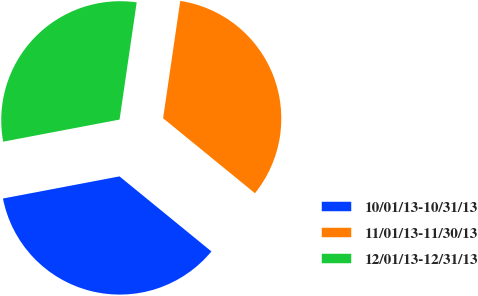Convert chart to OTSL. <chart><loc_0><loc_0><loc_500><loc_500><pie_chart><fcel>10/01/13-10/31/13<fcel>11/01/13-11/30/13<fcel>12/01/13-12/31/13<nl><fcel>36.12%<fcel>33.59%<fcel>30.3%<nl></chart> 